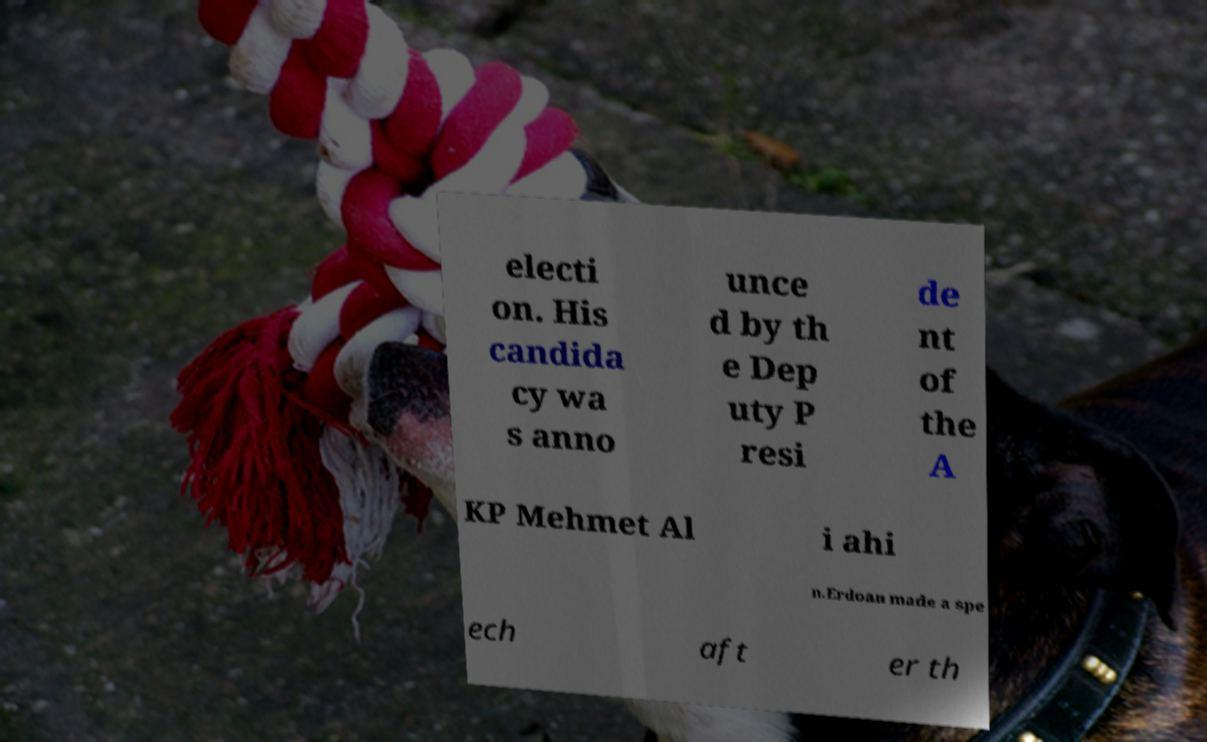Can you read and provide the text displayed in the image?This photo seems to have some interesting text. Can you extract and type it out for me? electi on. His candida cy wa s anno unce d by th e Dep uty P resi de nt of the A KP Mehmet Al i ahi n.Erdoan made a spe ech aft er th 